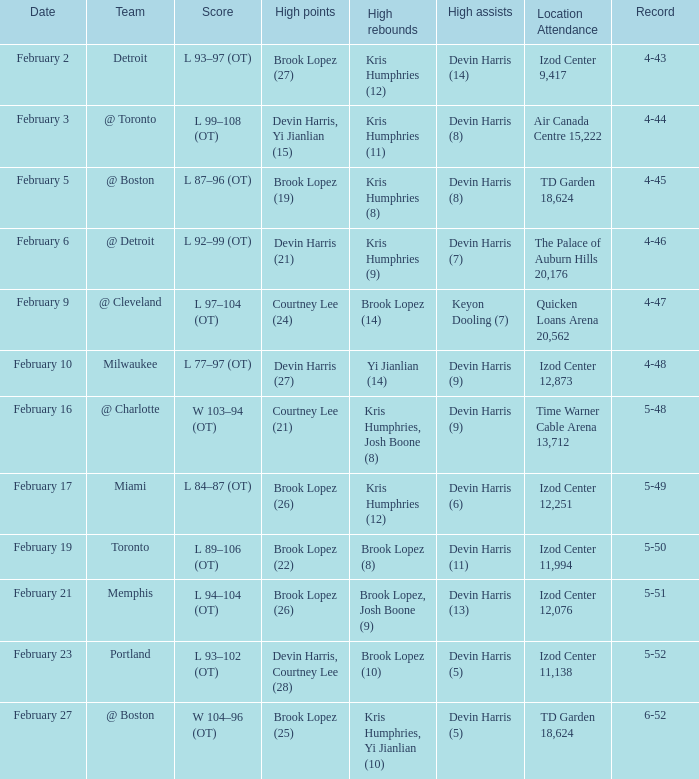What team was the game on February 27 played against? @ Boston. 